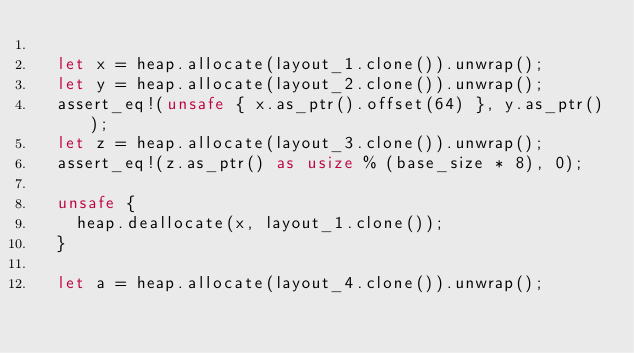<code> <loc_0><loc_0><loc_500><loc_500><_Rust_>
  let x = heap.allocate(layout_1.clone()).unwrap();
  let y = heap.allocate(layout_2.clone()).unwrap();
  assert_eq!(unsafe { x.as_ptr().offset(64) }, y.as_ptr());
  let z = heap.allocate(layout_3.clone()).unwrap();
  assert_eq!(z.as_ptr() as usize % (base_size * 8), 0);

  unsafe {
    heap.deallocate(x, layout_1.clone());
  }

  let a = heap.allocate(layout_4.clone()).unwrap();</code> 